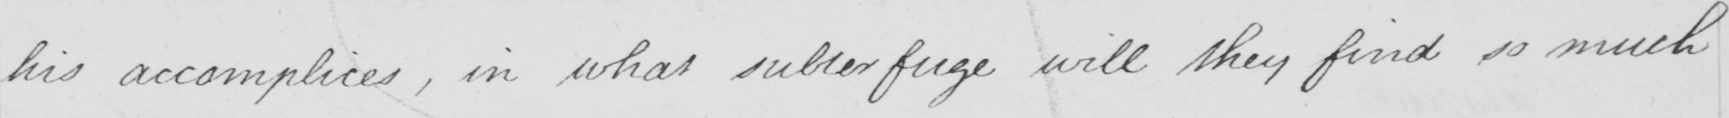Can you read and transcribe this handwriting? his accomplices , in what subterfuge will they find so much 